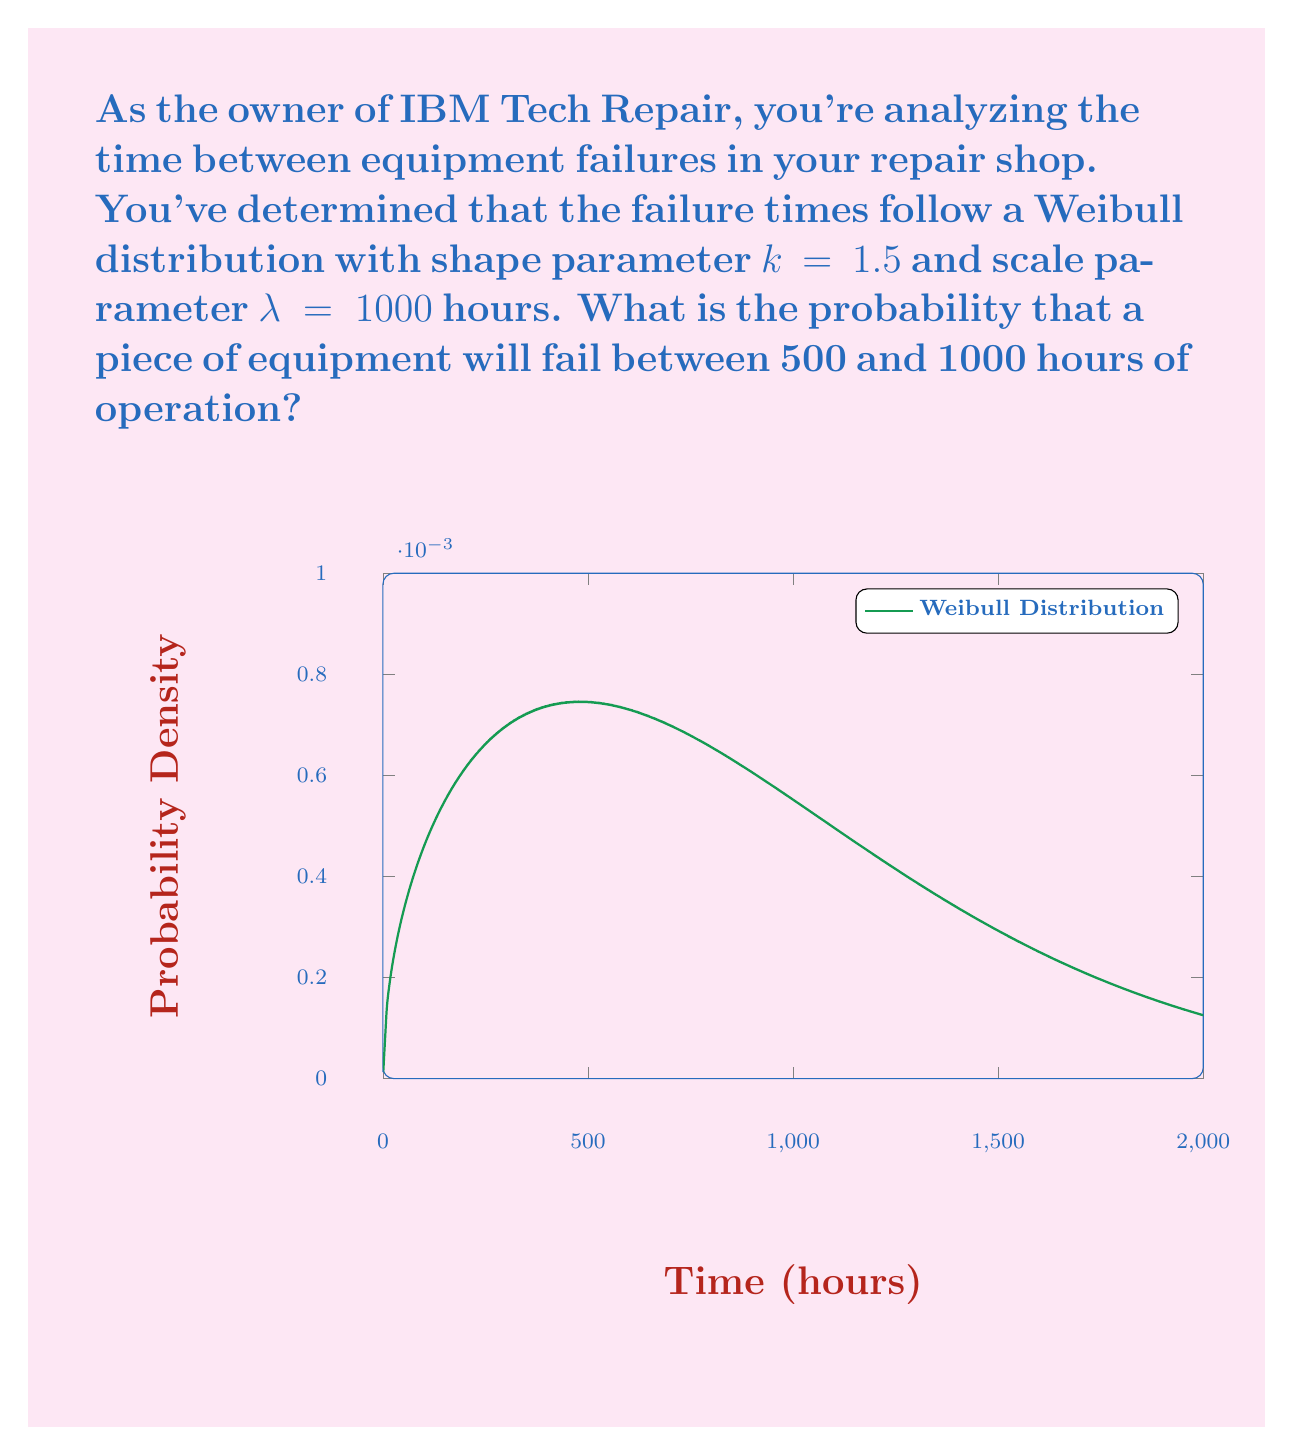Teach me how to tackle this problem. Let's approach this step-by-step:

1) The Weibull cumulative distribution function (CDF) is given by:

   $$F(t) = 1 - e^{-(\frac{t}{\lambda})^k}$$

2) We need to find $P(500 < T < 1000)$, which is equivalent to $F(1000) - F(500)$

3) Let's calculate $F(1000)$ first:
   $$F(1000) = 1 - e^{-(\frac{1000}{1000})^{1.5}} = 1 - e^{-1} \approx 0.6321$$

4) Now, let's calculate $F(500)$:
   $$F(500) = 1 - e^{-(\frac{500}{1000})^{1.5}} = 1 - e^{-(0.5)^{1.5}} \approx 0.2978$$

5) The probability we're looking for is:
   $$P(500 < T < 1000) = F(1000) - F(500) = 0.6321 - 0.2978 = 0.3343$$

6) Therefore, the probability that a piece of equipment will fail between 500 and 1000 hours of operation is approximately 0.3343 or 33.43%.
Answer: 0.3343 